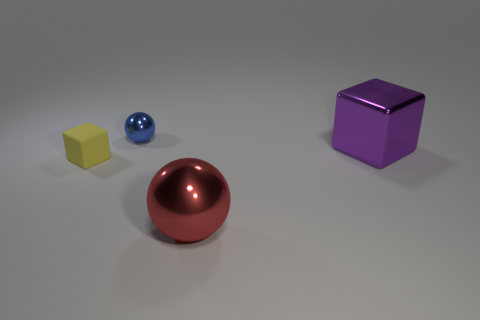Add 3 blue shiny balls. How many objects exist? 7 Add 2 small yellow things. How many small yellow things exist? 3 Subtract 0 blue cylinders. How many objects are left? 4 Subtract all purple metallic spheres. Subtract all yellow things. How many objects are left? 3 Add 1 yellow rubber blocks. How many yellow rubber blocks are left? 2 